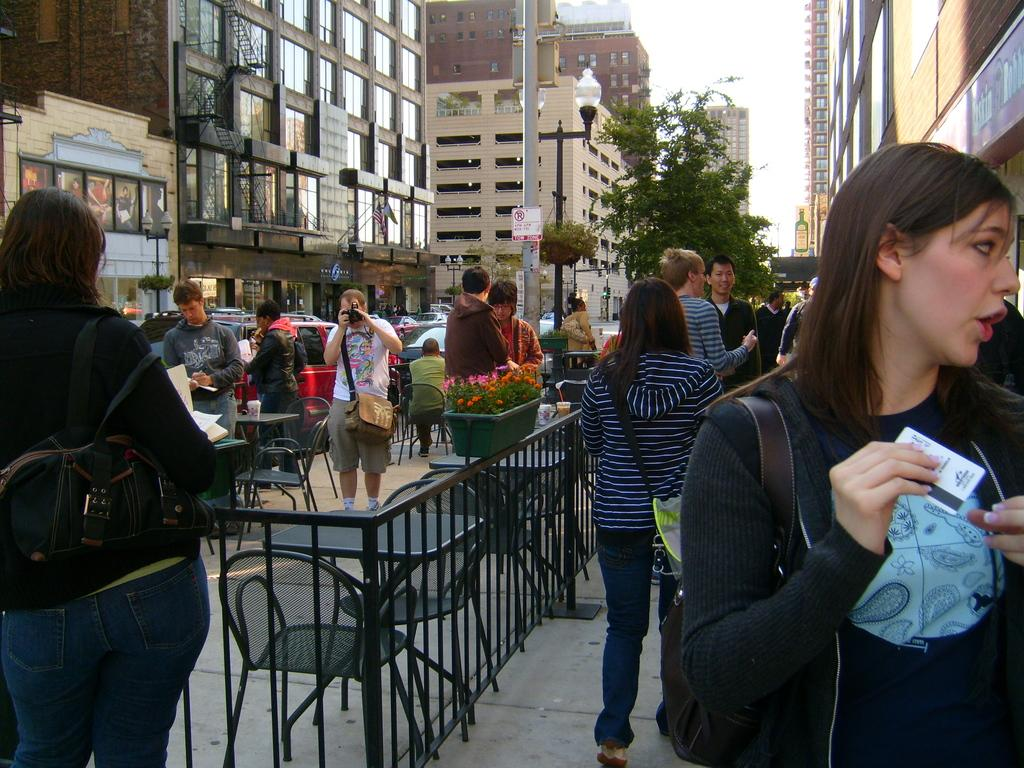How many people are in the image? There are people in the image, but the exact number is not specified. What are the people in the image doing? Some people are standing, while others are sitting on chairs. What can be seen in the background of the image? There is a pole, a building, a window, a tree, and the sky visible in the background of the image. What grade can be seen in the image? There is no mention of a grade or any educational context in the image. 